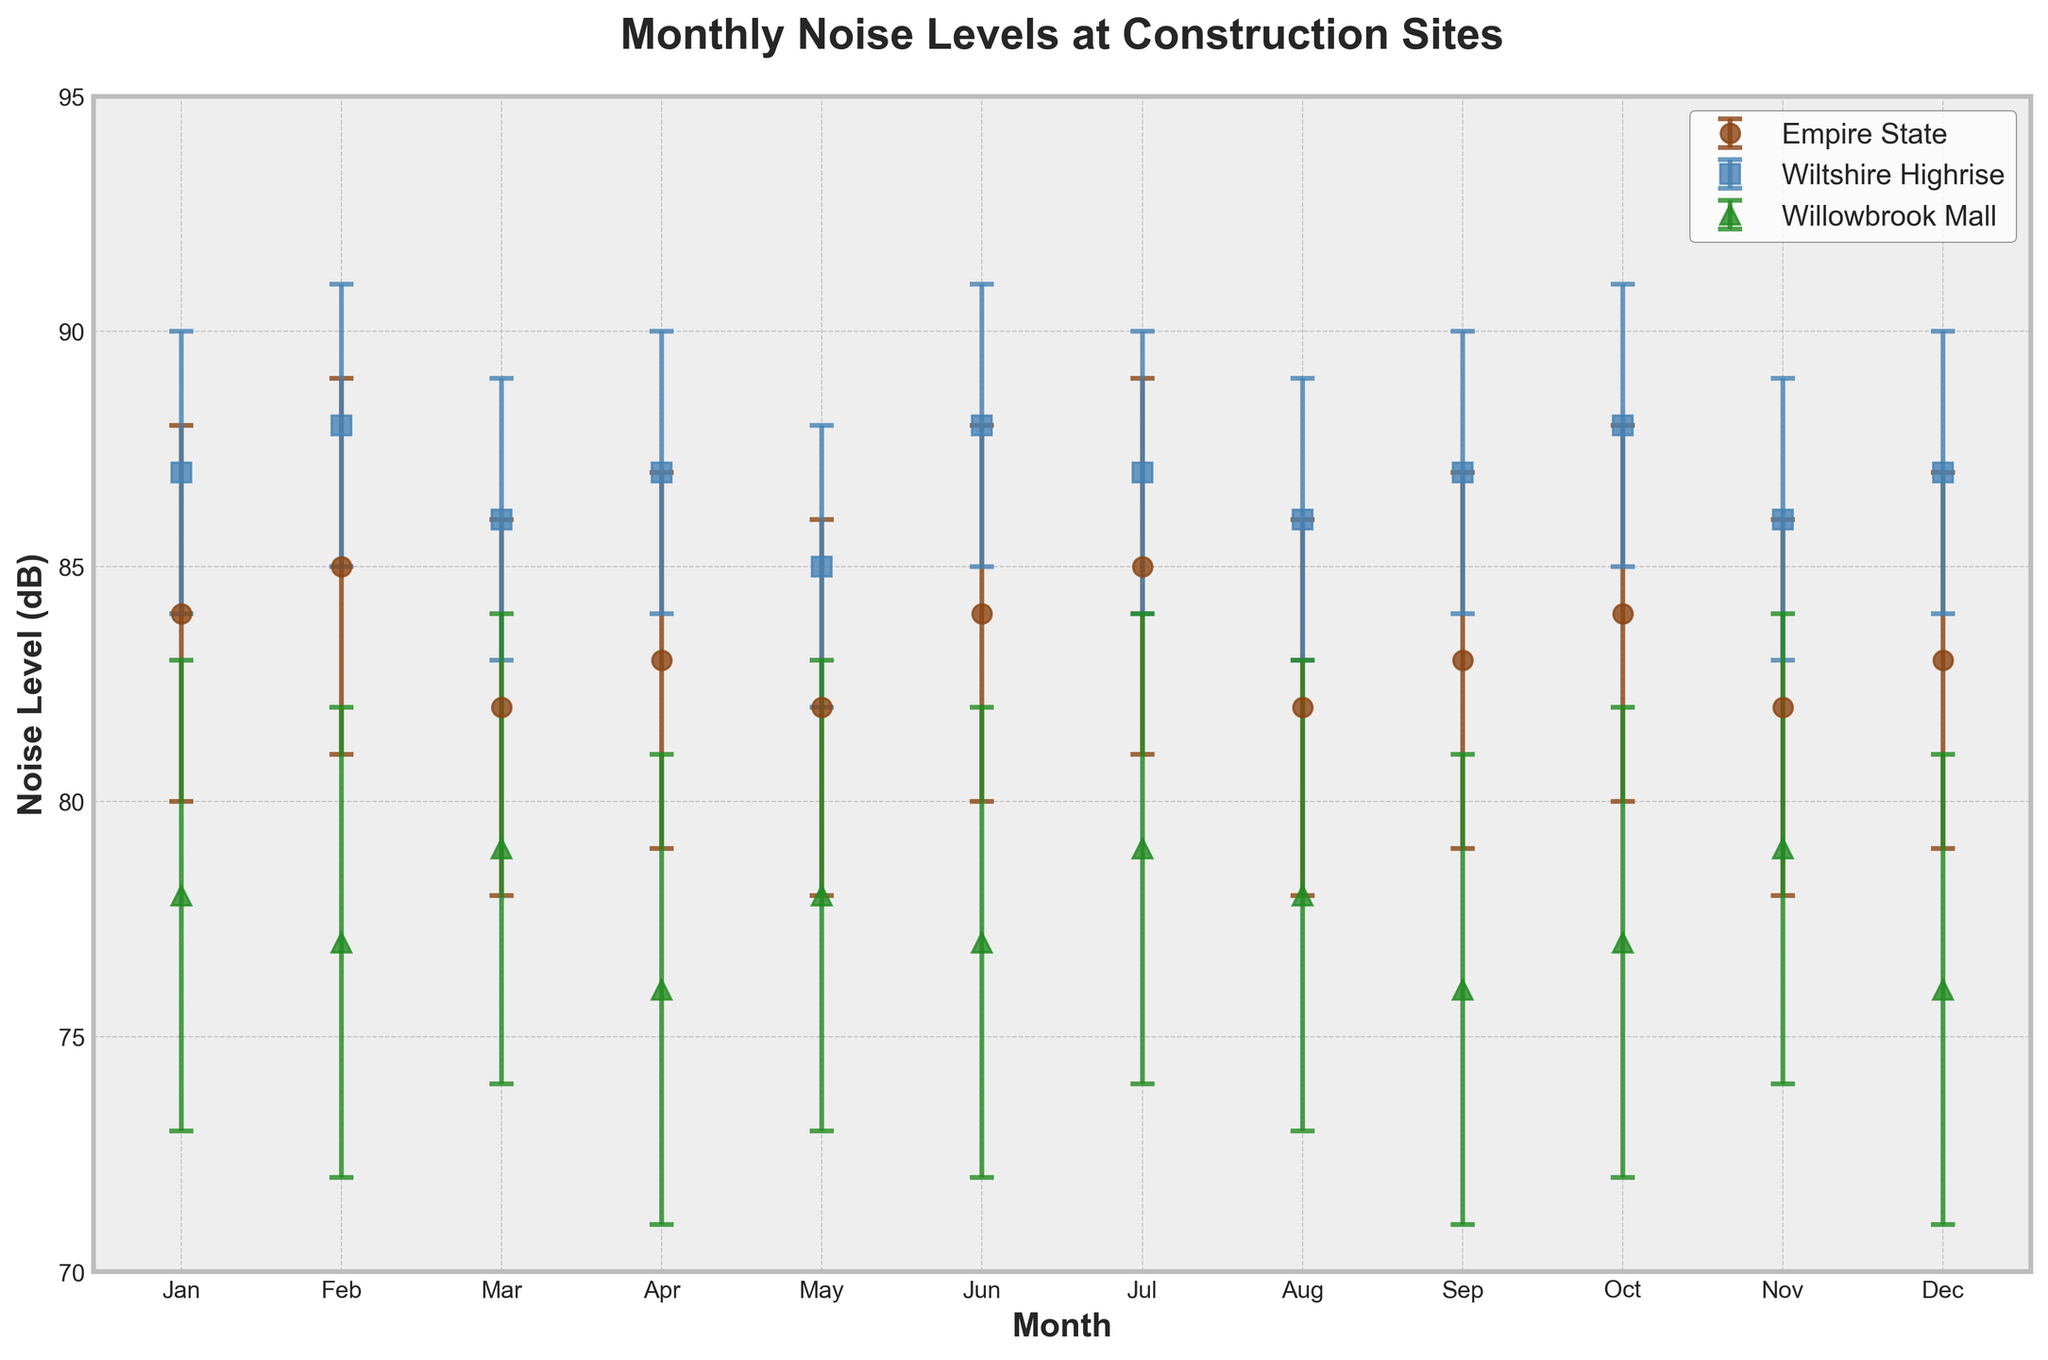What's the title of the plot? Look at the top center of the plot. The title is written in bold.
Answer: Monthly Noise Levels at Construction Sites What are the labels of the X and Y-axis? Check the text next to the horizontal and vertical axes.
Answer: Month, Noise Level (dB) What months are covered in the plot? Refer to the labels on the X-axis.
Answer: Jan, Feb, Mar, Apr, May, Jun, Jul, Aug, Sep, Oct, Nov, Dec Which site had the highest average noise level in January? Look at the data points for January. Compare the values of 'Empire State,' 'Wiltshire Highrise,' and 'Willowbrook Mall.'
Answer: Wiltshire Highrise How does the noise level at 'Empire State' in July compare to August? Identify the data points for July and August for 'Empire State' and check their values.
Answer: July is higher than August For 'Willowbrook Mall,' which month has the minimum average noise level? Look at the values of 'Willowbrook Mall' and find the lowest point.
Answer: April What’s the range of the noise levels for ‘Empire State’ between January and December? Identify the maximum and minimum average noise levels for 'Empire State' from January to December, then subtract the minimum from the maximum.
Answer: 85 - 82 = 3 dB Which construction site generally maintained the lowest average noise levels throughout the year? Compare the average noise levels across all months for each site and identify the one with consistently lower values.
Answer: Willowbrook Mall What is the total noise level for 'Wiltshire Highrise' in February and March combined? Sum up the average noise levels for Wiltshire Highrise in February and March.
Answer: 88 + 86 = 174 dB Are the error bars for 'Empire State' of equal length across all months? Look at the error bars on 'Empire State' data points and check their lengths.
Answer: Yes 